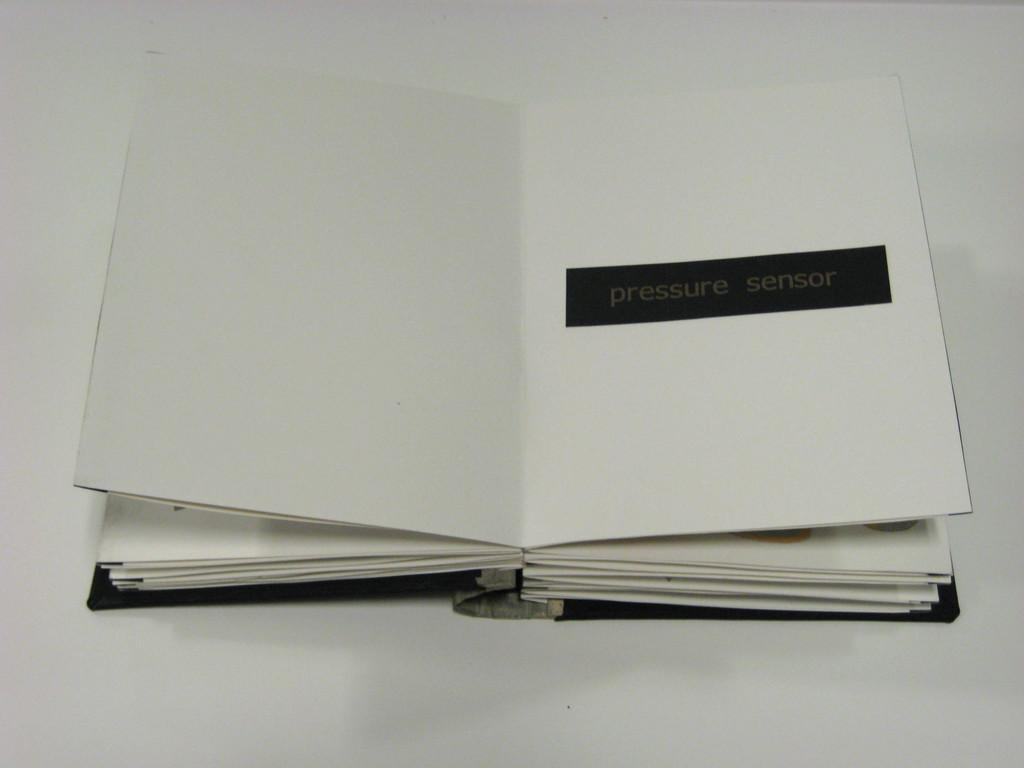<image>
Render a clear and concise summary of the photo. An open white book has a black bar saying pressure sensor in the middle of one page. 